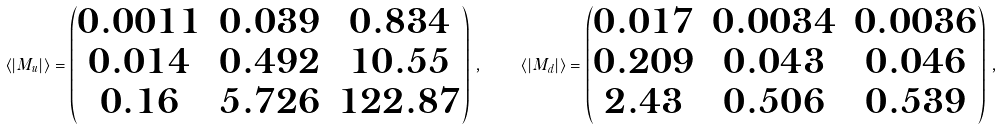<formula> <loc_0><loc_0><loc_500><loc_500>\langle | M _ { u } | \rangle = \begin{pmatrix} 0 . 0 0 1 1 & 0 . 0 3 9 & 0 . 8 3 4 \\ 0 . 0 1 4 & 0 . 4 9 2 & 1 0 . 5 5 \\ 0 . 1 6 & 5 . 7 2 6 & 1 2 2 . 8 7 \end{pmatrix} \, , \quad \langle | M _ { d } | \rangle = \begin{pmatrix} 0 . 0 1 7 & 0 . 0 0 3 4 & 0 . 0 0 3 6 \\ 0 . 2 0 9 & 0 . 0 4 3 & 0 . 0 4 6 \\ 2 . 4 3 & 0 . 5 0 6 & 0 . 5 3 9 \end{pmatrix} \, ,</formula> 